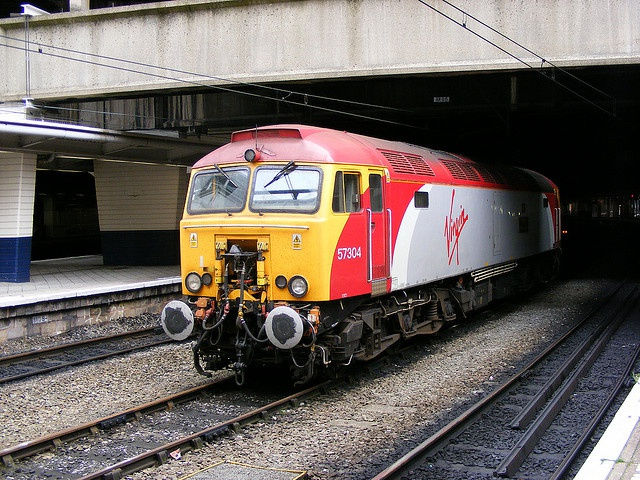Describe the objects in this image and their specific colors. I can see a train in black, lightgray, gray, and darkgray tones in this image. 